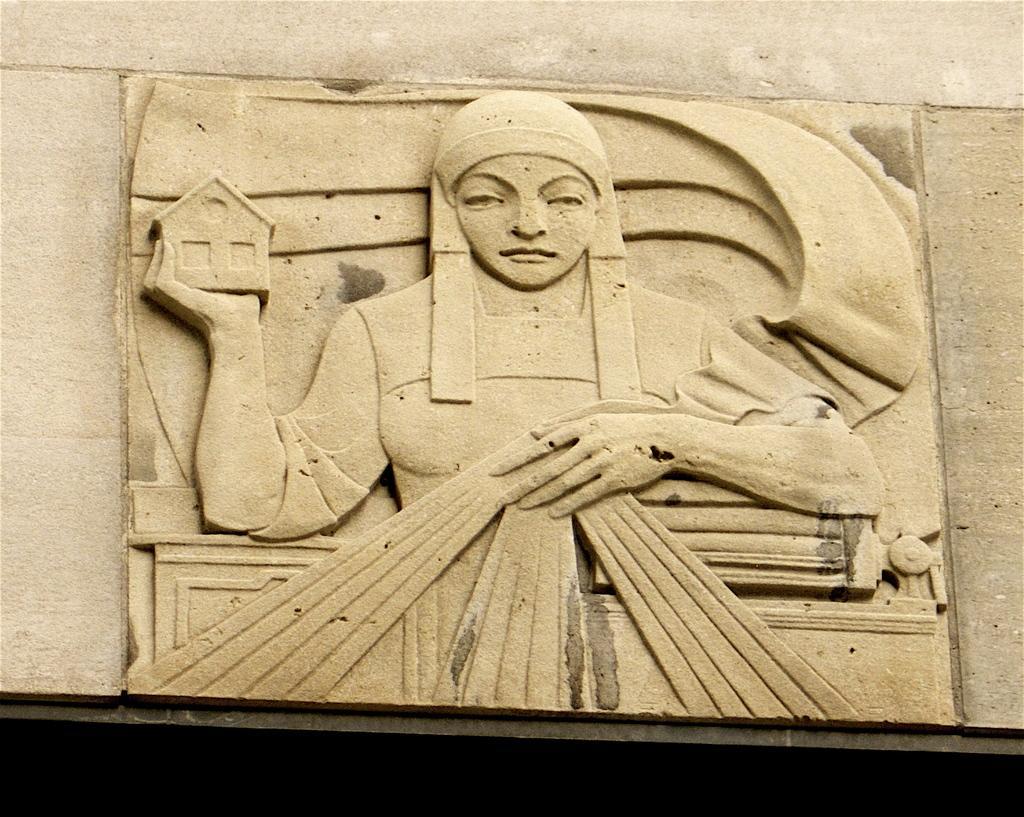How would you summarize this image in a sentence or two? Here we can see stone carving on a platform. 